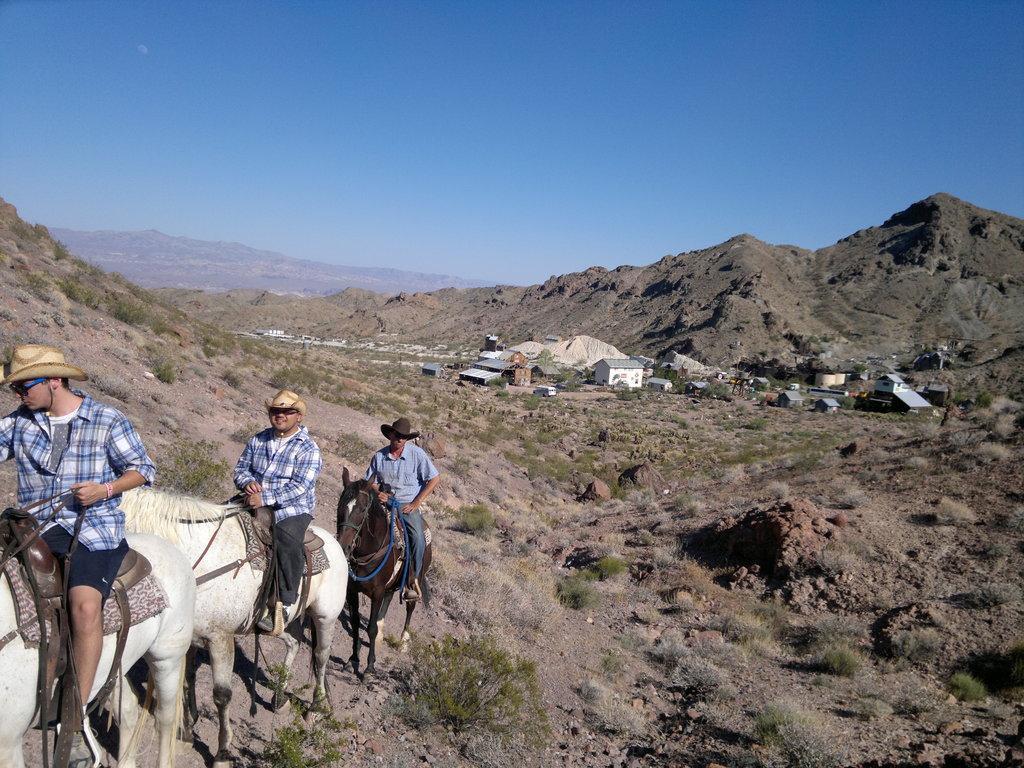Can you describe this image briefly? In this image there are shelters, grass, rocks, horses, people, hills and blue sky. People are sitting on horses and wearing hats. 